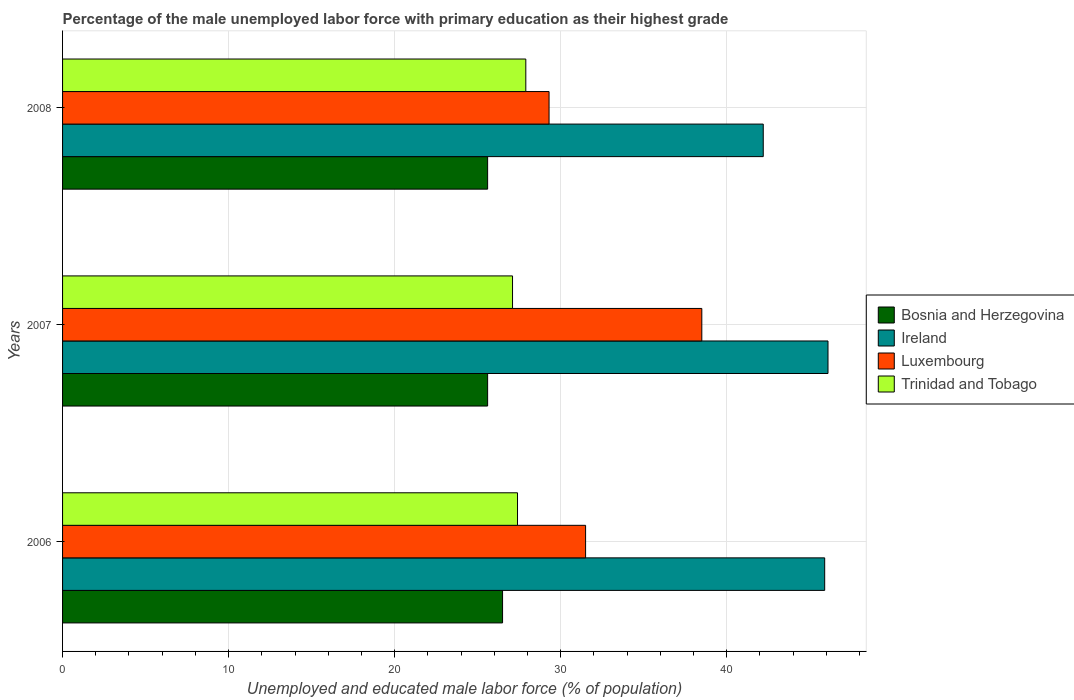How many different coloured bars are there?
Provide a short and direct response. 4. Are the number of bars on each tick of the Y-axis equal?
Your answer should be compact. Yes. How many bars are there on the 2nd tick from the top?
Keep it short and to the point. 4. What is the label of the 2nd group of bars from the top?
Your response must be concise. 2007. In how many cases, is the number of bars for a given year not equal to the number of legend labels?
Your answer should be very brief. 0. What is the percentage of the unemployed male labor force with primary education in Ireland in 2008?
Your answer should be very brief. 42.2. Across all years, what is the maximum percentage of the unemployed male labor force with primary education in Bosnia and Herzegovina?
Keep it short and to the point. 26.5. Across all years, what is the minimum percentage of the unemployed male labor force with primary education in Trinidad and Tobago?
Keep it short and to the point. 27.1. In which year was the percentage of the unemployed male labor force with primary education in Luxembourg maximum?
Provide a succinct answer. 2007. What is the total percentage of the unemployed male labor force with primary education in Ireland in the graph?
Your answer should be compact. 134.2. What is the difference between the percentage of the unemployed male labor force with primary education in Ireland in 2006 and that in 2007?
Offer a very short reply. -0.2. What is the difference between the percentage of the unemployed male labor force with primary education in Luxembourg in 2006 and the percentage of the unemployed male labor force with primary education in Ireland in 2008?
Offer a very short reply. -10.7. What is the average percentage of the unemployed male labor force with primary education in Bosnia and Herzegovina per year?
Offer a terse response. 25.9. In the year 2007, what is the difference between the percentage of the unemployed male labor force with primary education in Ireland and percentage of the unemployed male labor force with primary education in Trinidad and Tobago?
Your answer should be compact. 19. What is the ratio of the percentage of the unemployed male labor force with primary education in Ireland in 2006 to that in 2007?
Ensure brevity in your answer.  1. Is the difference between the percentage of the unemployed male labor force with primary education in Ireland in 2007 and 2008 greater than the difference between the percentage of the unemployed male labor force with primary education in Trinidad and Tobago in 2007 and 2008?
Give a very brief answer. Yes. What is the difference between the highest and the second highest percentage of the unemployed male labor force with primary education in Trinidad and Tobago?
Offer a very short reply. 0.5. What is the difference between the highest and the lowest percentage of the unemployed male labor force with primary education in Ireland?
Your answer should be compact. 3.9. In how many years, is the percentage of the unemployed male labor force with primary education in Luxembourg greater than the average percentage of the unemployed male labor force with primary education in Luxembourg taken over all years?
Your answer should be compact. 1. Is the sum of the percentage of the unemployed male labor force with primary education in Luxembourg in 2007 and 2008 greater than the maximum percentage of the unemployed male labor force with primary education in Bosnia and Herzegovina across all years?
Your answer should be very brief. Yes. Is it the case that in every year, the sum of the percentage of the unemployed male labor force with primary education in Trinidad and Tobago and percentage of the unemployed male labor force with primary education in Bosnia and Herzegovina is greater than the sum of percentage of the unemployed male labor force with primary education in Luxembourg and percentage of the unemployed male labor force with primary education in Ireland?
Offer a terse response. No. What does the 4th bar from the top in 2007 represents?
Ensure brevity in your answer.  Bosnia and Herzegovina. What does the 2nd bar from the bottom in 2008 represents?
Keep it short and to the point. Ireland. How many years are there in the graph?
Offer a terse response. 3. Does the graph contain grids?
Ensure brevity in your answer.  Yes. Where does the legend appear in the graph?
Your answer should be very brief. Center right. How many legend labels are there?
Provide a short and direct response. 4. How are the legend labels stacked?
Provide a succinct answer. Vertical. What is the title of the graph?
Your answer should be compact. Percentage of the male unemployed labor force with primary education as their highest grade. What is the label or title of the X-axis?
Your answer should be very brief. Unemployed and educated male labor force (% of population). What is the label or title of the Y-axis?
Your response must be concise. Years. What is the Unemployed and educated male labor force (% of population) in Bosnia and Herzegovina in 2006?
Offer a very short reply. 26.5. What is the Unemployed and educated male labor force (% of population) of Ireland in 2006?
Make the answer very short. 45.9. What is the Unemployed and educated male labor force (% of population) of Luxembourg in 2006?
Offer a very short reply. 31.5. What is the Unemployed and educated male labor force (% of population) in Trinidad and Tobago in 2006?
Provide a short and direct response. 27.4. What is the Unemployed and educated male labor force (% of population) of Bosnia and Herzegovina in 2007?
Keep it short and to the point. 25.6. What is the Unemployed and educated male labor force (% of population) of Ireland in 2007?
Provide a short and direct response. 46.1. What is the Unemployed and educated male labor force (% of population) in Luxembourg in 2007?
Your answer should be very brief. 38.5. What is the Unemployed and educated male labor force (% of population) in Trinidad and Tobago in 2007?
Give a very brief answer. 27.1. What is the Unemployed and educated male labor force (% of population) of Bosnia and Herzegovina in 2008?
Provide a succinct answer. 25.6. What is the Unemployed and educated male labor force (% of population) of Ireland in 2008?
Keep it short and to the point. 42.2. What is the Unemployed and educated male labor force (% of population) of Luxembourg in 2008?
Keep it short and to the point. 29.3. What is the Unemployed and educated male labor force (% of population) in Trinidad and Tobago in 2008?
Your answer should be very brief. 27.9. Across all years, what is the maximum Unemployed and educated male labor force (% of population) of Bosnia and Herzegovina?
Offer a very short reply. 26.5. Across all years, what is the maximum Unemployed and educated male labor force (% of population) of Ireland?
Provide a short and direct response. 46.1. Across all years, what is the maximum Unemployed and educated male labor force (% of population) of Luxembourg?
Give a very brief answer. 38.5. Across all years, what is the maximum Unemployed and educated male labor force (% of population) of Trinidad and Tobago?
Offer a terse response. 27.9. Across all years, what is the minimum Unemployed and educated male labor force (% of population) of Bosnia and Herzegovina?
Your answer should be compact. 25.6. Across all years, what is the minimum Unemployed and educated male labor force (% of population) of Ireland?
Your answer should be compact. 42.2. Across all years, what is the minimum Unemployed and educated male labor force (% of population) in Luxembourg?
Your response must be concise. 29.3. Across all years, what is the minimum Unemployed and educated male labor force (% of population) of Trinidad and Tobago?
Provide a succinct answer. 27.1. What is the total Unemployed and educated male labor force (% of population) of Bosnia and Herzegovina in the graph?
Your answer should be compact. 77.7. What is the total Unemployed and educated male labor force (% of population) in Ireland in the graph?
Provide a short and direct response. 134.2. What is the total Unemployed and educated male labor force (% of population) in Luxembourg in the graph?
Keep it short and to the point. 99.3. What is the total Unemployed and educated male labor force (% of population) of Trinidad and Tobago in the graph?
Offer a very short reply. 82.4. What is the difference between the Unemployed and educated male labor force (% of population) in Ireland in 2006 and that in 2007?
Provide a succinct answer. -0.2. What is the difference between the Unemployed and educated male labor force (% of population) of Luxembourg in 2006 and that in 2007?
Your answer should be very brief. -7. What is the difference between the Unemployed and educated male labor force (% of population) of Trinidad and Tobago in 2006 and that in 2007?
Provide a short and direct response. 0.3. What is the difference between the Unemployed and educated male labor force (% of population) in Trinidad and Tobago in 2006 and that in 2008?
Keep it short and to the point. -0.5. What is the difference between the Unemployed and educated male labor force (% of population) in Bosnia and Herzegovina in 2007 and that in 2008?
Your response must be concise. 0. What is the difference between the Unemployed and educated male labor force (% of population) of Ireland in 2007 and that in 2008?
Offer a terse response. 3.9. What is the difference between the Unemployed and educated male labor force (% of population) of Luxembourg in 2007 and that in 2008?
Offer a very short reply. 9.2. What is the difference between the Unemployed and educated male labor force (% of population) in Bosnia and Herzegovina in 2006 and the Unemployed and educated male labor force (% of population) in Ireland in 2007?
Provide a short and direct response. -19.6. What is the difference between the Unemployed and educated male labor force (% of population) of Bosnia and Herzegovina in 2006 and the Unemployed and educated male labor force (% of population) of Luxembourg in 2007?
Ensure brevity in your answer.  -12. What is the difference between the Unemployed and educated male labor force (% of population) of Bosnia and Herzegovina in 2006 and the Unemployed and educated male labor force (% of population) of Trinidad and Tobago in 2007?
Offer a very short reply. -0.6. What is the difference between the Unemployed and educated male labor force (% of population) of Bosnia and Herzegovina in 2006 and the Unemployed and educated male labor force (% of population) of Ireland in 2008?
Your response must be concise. -15.7. What is the difference between the Unemployed and educated male labor force (% of population) of Bosnia and Herzegovina in 2007 and the Unemployed and educated male labor force (% of population) of Ireland in 2008?
Make the answer very short. -16.6. What is the difference between the Unemployed and educated male labor force (% of population) in Bosnia and Herzegovina in 2007 and the Unemployed and educated male labor force (% of population) in Trinidad and Tobago in 2008?
Provide a succinct answer. -2.3. What is the difference between the Unemployed and educated male labor force (% of population) in Ireland in 2007 and the Unemployed and educated male labor force (% of population) in Luxembourg in 2008?
Provide a succinct answer. 16.8. What is the difference between the Unemployed and educated male labor force (% of population) of Ireland in 2007 and the Unemployed and educated male labor force (% of population) of Trinidad and Tobago in 2008?
Provide a short and direct response. 18.2. What is the difference between the Unemployed and educated male labor force (% of population) in Luxembourg in 2007 and the Unemployed and educated male labor force (% of population) in Trinidad and Tobago in 2008?
Offer a very short reply. 10.6. What is the average Unemployed and educated male labor force (% of population) in Bosnia and Herzegovina per year?
Your answer should be very brief. 25.9. What is the average Unemployed and educated male labor force (% of population) of Ireland per year?
Make the answer very short. 44.73. What is the average Unemployed and educated male labor force (% of population) of Luxembourg per year?
Your answer should be compact. 33.1. What is the average Unemployed and educated male labor force (% of population) of Trinidad and Tobago per year?
Keep it short and to the point. 27.47. In the year 2006, what is the difference between the Unemployed and educated male labor force (% of population) in Bosnia and Herzegovina and Unemployed and educated male labor force (% of population) in Ireland?
Your response must be concise. -19.4. In the year 2006, what is the difference between the Unemployed and educated male labor force (% of population) of Bosnia and Herzegovina and Unemployed and educated male labor force (% of population) of Luxembourg?
Keep it short and to the point. -5. In the year 2006, what is the difference between the Unemployed and educated male labor force (% of population) in Ireland and Unemployed and educated male labor force (% of population) in Luxembourg?
Ensure brevity in your answer.  14.4. In the year 2006, what is the difference between the Unemployed and educated male labor force (% of population) in Luxembourg and Unemployed and educated male labor force (% of population) in Trinidad and Tobago?
Ensure brevity in your answer.  4.1. In the year 2007, what is the difference between the Unemployed and educated male labor force (% of population) of Bosnia and Herzegovina and Unemployed and educated male labor force (% of population) of Ireland?
Give a very brief answer. -20.5. In the year 2007, what is the difference between the Unemployed and educated male labor force (% of population) in Bosnia and Herzegovina and Unemployed and educated male labor force (% of population) in Luxembourg?
Ensure brevity in your answer.  -12.9. In the year 2008, what is the difference between the Unemployed and educated male labor force (% of population) in Bosnia and Herzegovina and Unemployed and educated male labor force (% of population) in Ireland?
Keep it short and to the point. -16.6. In the year 2008, what is the difference between the Unemployed and educated male labor force (% of population) of Bosnia and Herzegovina and Unemployed and educated male labor force (% of population) of Trinidad and Tobago?
Your answer should be compact. -2.3. In the year 2008, what is the difference between the Unemployed and educated male labor force (% of population) of Ireland and Unemployed and educated male labor force (% of population) of Luxembourg?
Keep it short and to the point. 12.9. In the year 2008, what is the difference between the Unemployed and educated male labor force (% of population) in Ireland and Unemployed and educated male labor force (% of population) in Trinidad and Tobago?
Provide a succinct answer. 14.3. In the year 2008, what is the difference between the Unemployed and educated male labor force (% of population) of Luxembourg and Unemployed and educated male labor force (% of population) of Trinidad and Tobago?
Your response must be concise. 1.4. What is the ratio of the Unemployed and educated male labor force (% of population) in Bosnia and Herzegovina in 2006 to that in 2007?
Offer a terse response. 1.04. What is the ratio of the Unemployed and educated male labor force (% of population) in Ireland in 2006 to that in 2007?
Make the answer very short. 1. What is the ratio of the Unemployed and educated male labor force (% of population) of Luxembourg in 2006 to that in 2007?
Your response must be concise. 0.82. What is the ratio of the Unemployed and educated male labor force (% of population) of Trinidad and Tobago in 2006 to that in 2007?
Offer a terse response. 1.01. What is the ratio of the Unemployed and educated male labor force (% of population) in Bosnia and Herzegovina in 2006 to that in 2008?
Offer a very short reply. 1.04. What is the ratio of the Unemployed and educated male labor force (% of population) of Ireland in 2006 to that in 2008?
Your answer should be compact. 1.09. What is the ratio of the Unemployed and educated male labor force (% of population) in Luxembourg in 2006 to that in 2008?
Your answer should be compact. 1.08. What is the ratio of the Unemployed and educated male labor force (% of population) of Trinidad and Tobago in 2006 to that in 2008?
Provide a succinct answer. 0.98. What is the ratio of the Unemployed and educated male labor force (% of population) of Bosnia and Herzegovina in 2007 to that in 2008?
Your answer should be very brief. 1. What is the ratio of the Unemployed and educated male labor force (% of population) of Ireland in 2007 to that in 2008?
Ensure brevity in your answer.  1.09. What is the ratio of the Unemployed and educated male labor force (% of population) in Luxembourg in 2007 to that in 2008?
Your response must be concise. 1.31. What is the ratio of the Unemployed and educated male labor force (% of population) in Trinidad and Tobago in 2007 to that in 2008?
Ensure brevity in your answer.  0.97. What is the difference between the highest and the second highest Unemployed and educated male labor force (% of population) of Bosnia and Herzegovina?
Your answer should be compact. 0.9. What is the difference between the highest and the second highest Unemployed and educated male labor force (% of population) of Luxembourg?
Your response must be concise. 7. What is the difference between the highest and the lowest Unemployed and educated male labor force (% of population) of Ireland?
Provide a succinct answer. 3.9. 